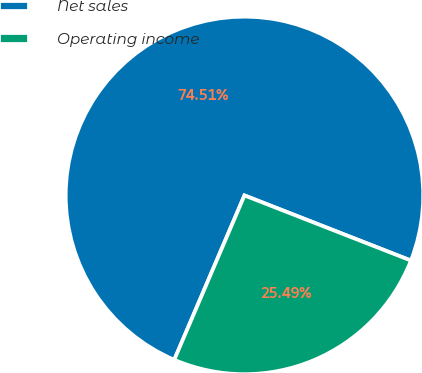Convert chart to OTSL. <chart><loc_0><loc_0><loc_500><loc_500><pie_chart><fcel>Net sales<fcel>Operating income<nl><fcel>74.51%<fcel>25.49%<nl></chart> 